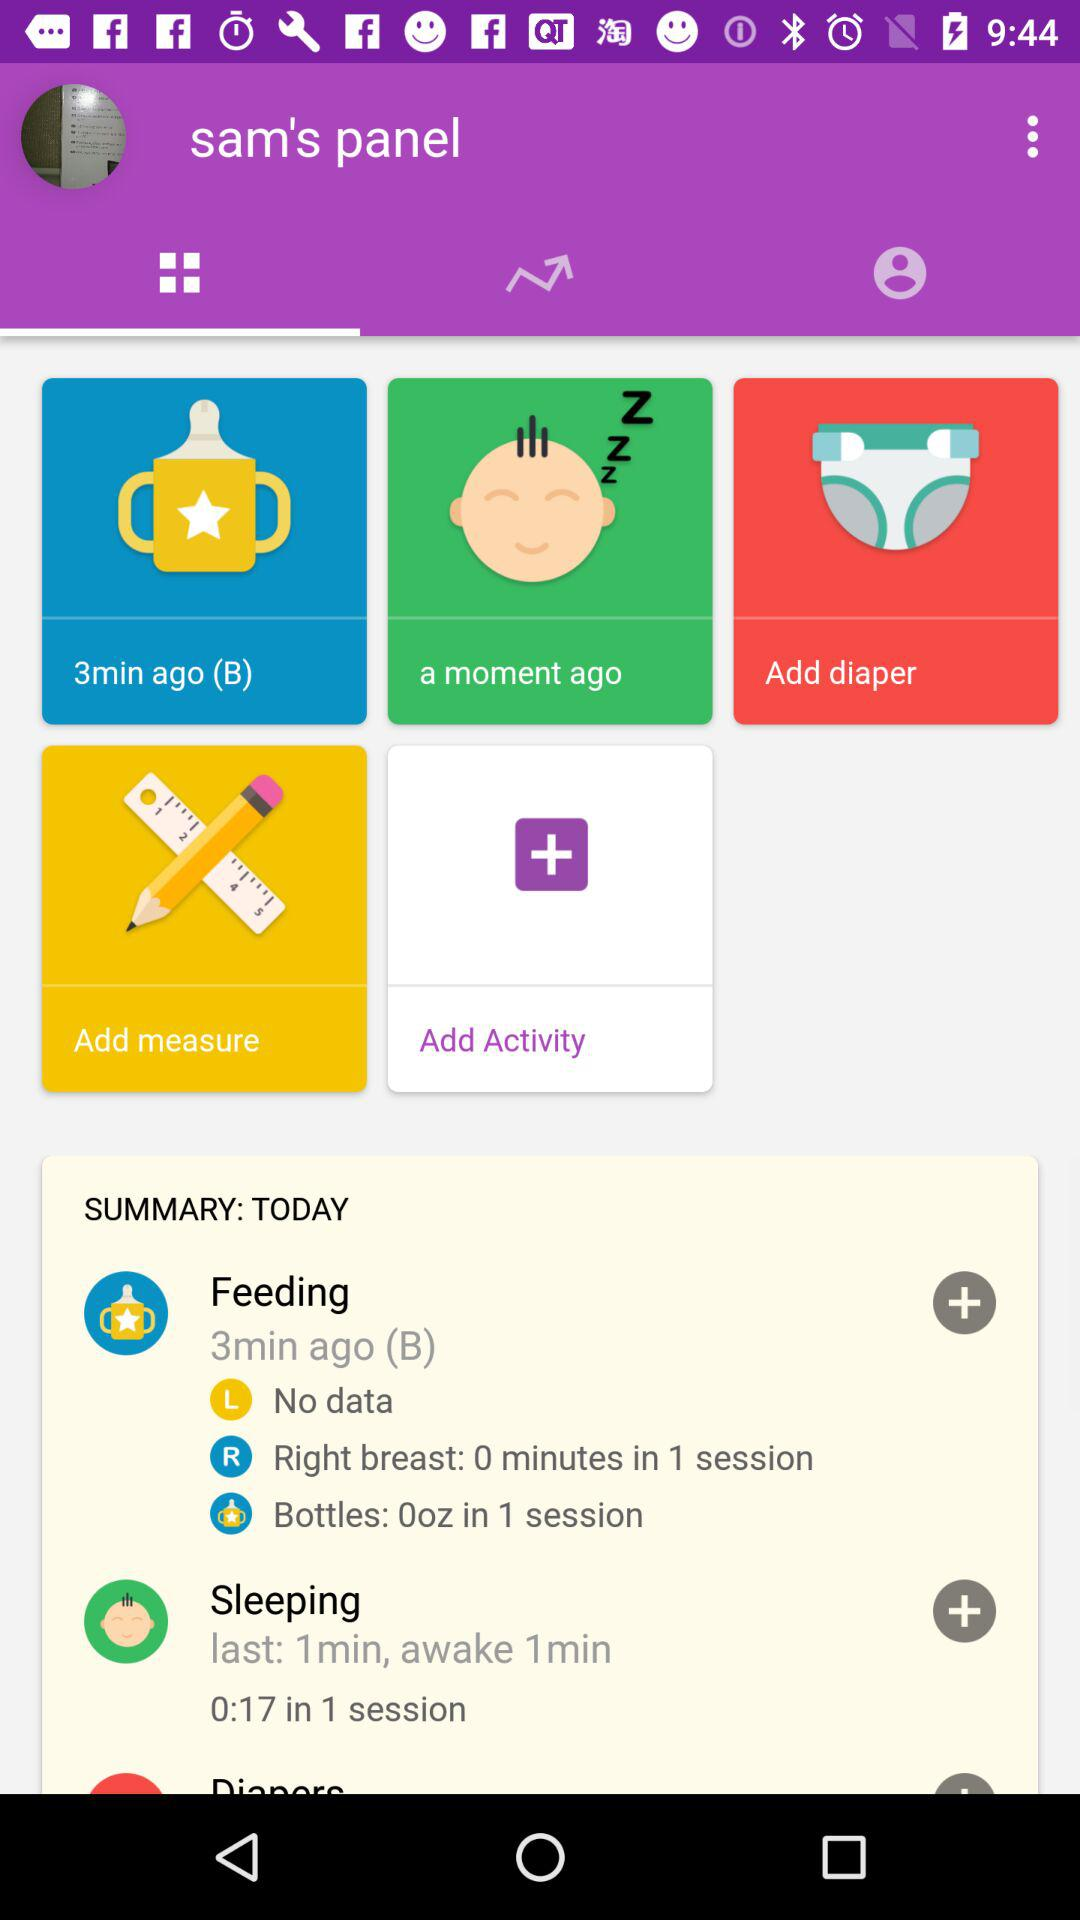How long ago did the baby sleep? The baby got to sleep a moment ago. 